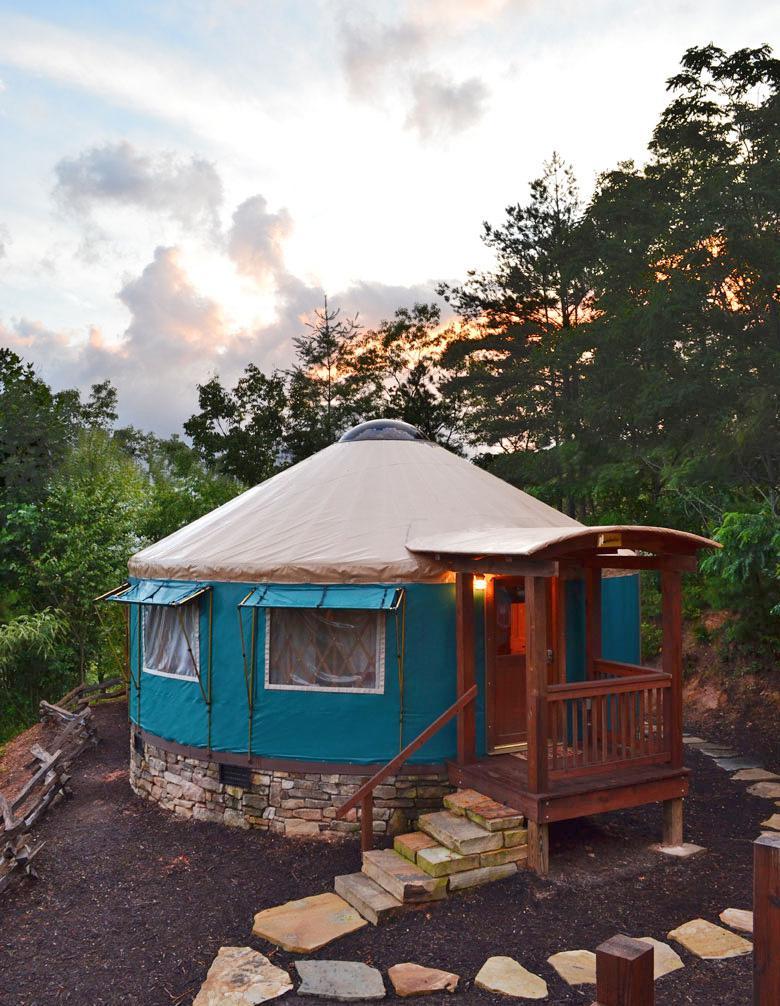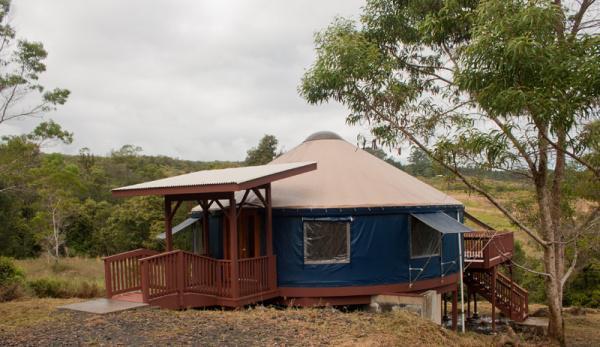The first image is the image on the left, the second image is the image on the right. Analyze the images presented: Is the assertion "Each image shows the exterior of one yurt, featuring some type of wood deck and railing." valid? Answer yes or no. Yes. The first image is the image on the left, the second image is the image on the right. For the images shown, is this caption "Each image shows the front door of a single-story yurt with a roof that contrasts the walls, and a wooden decking entrance with railings." true? Answer yes or no. Yes. 